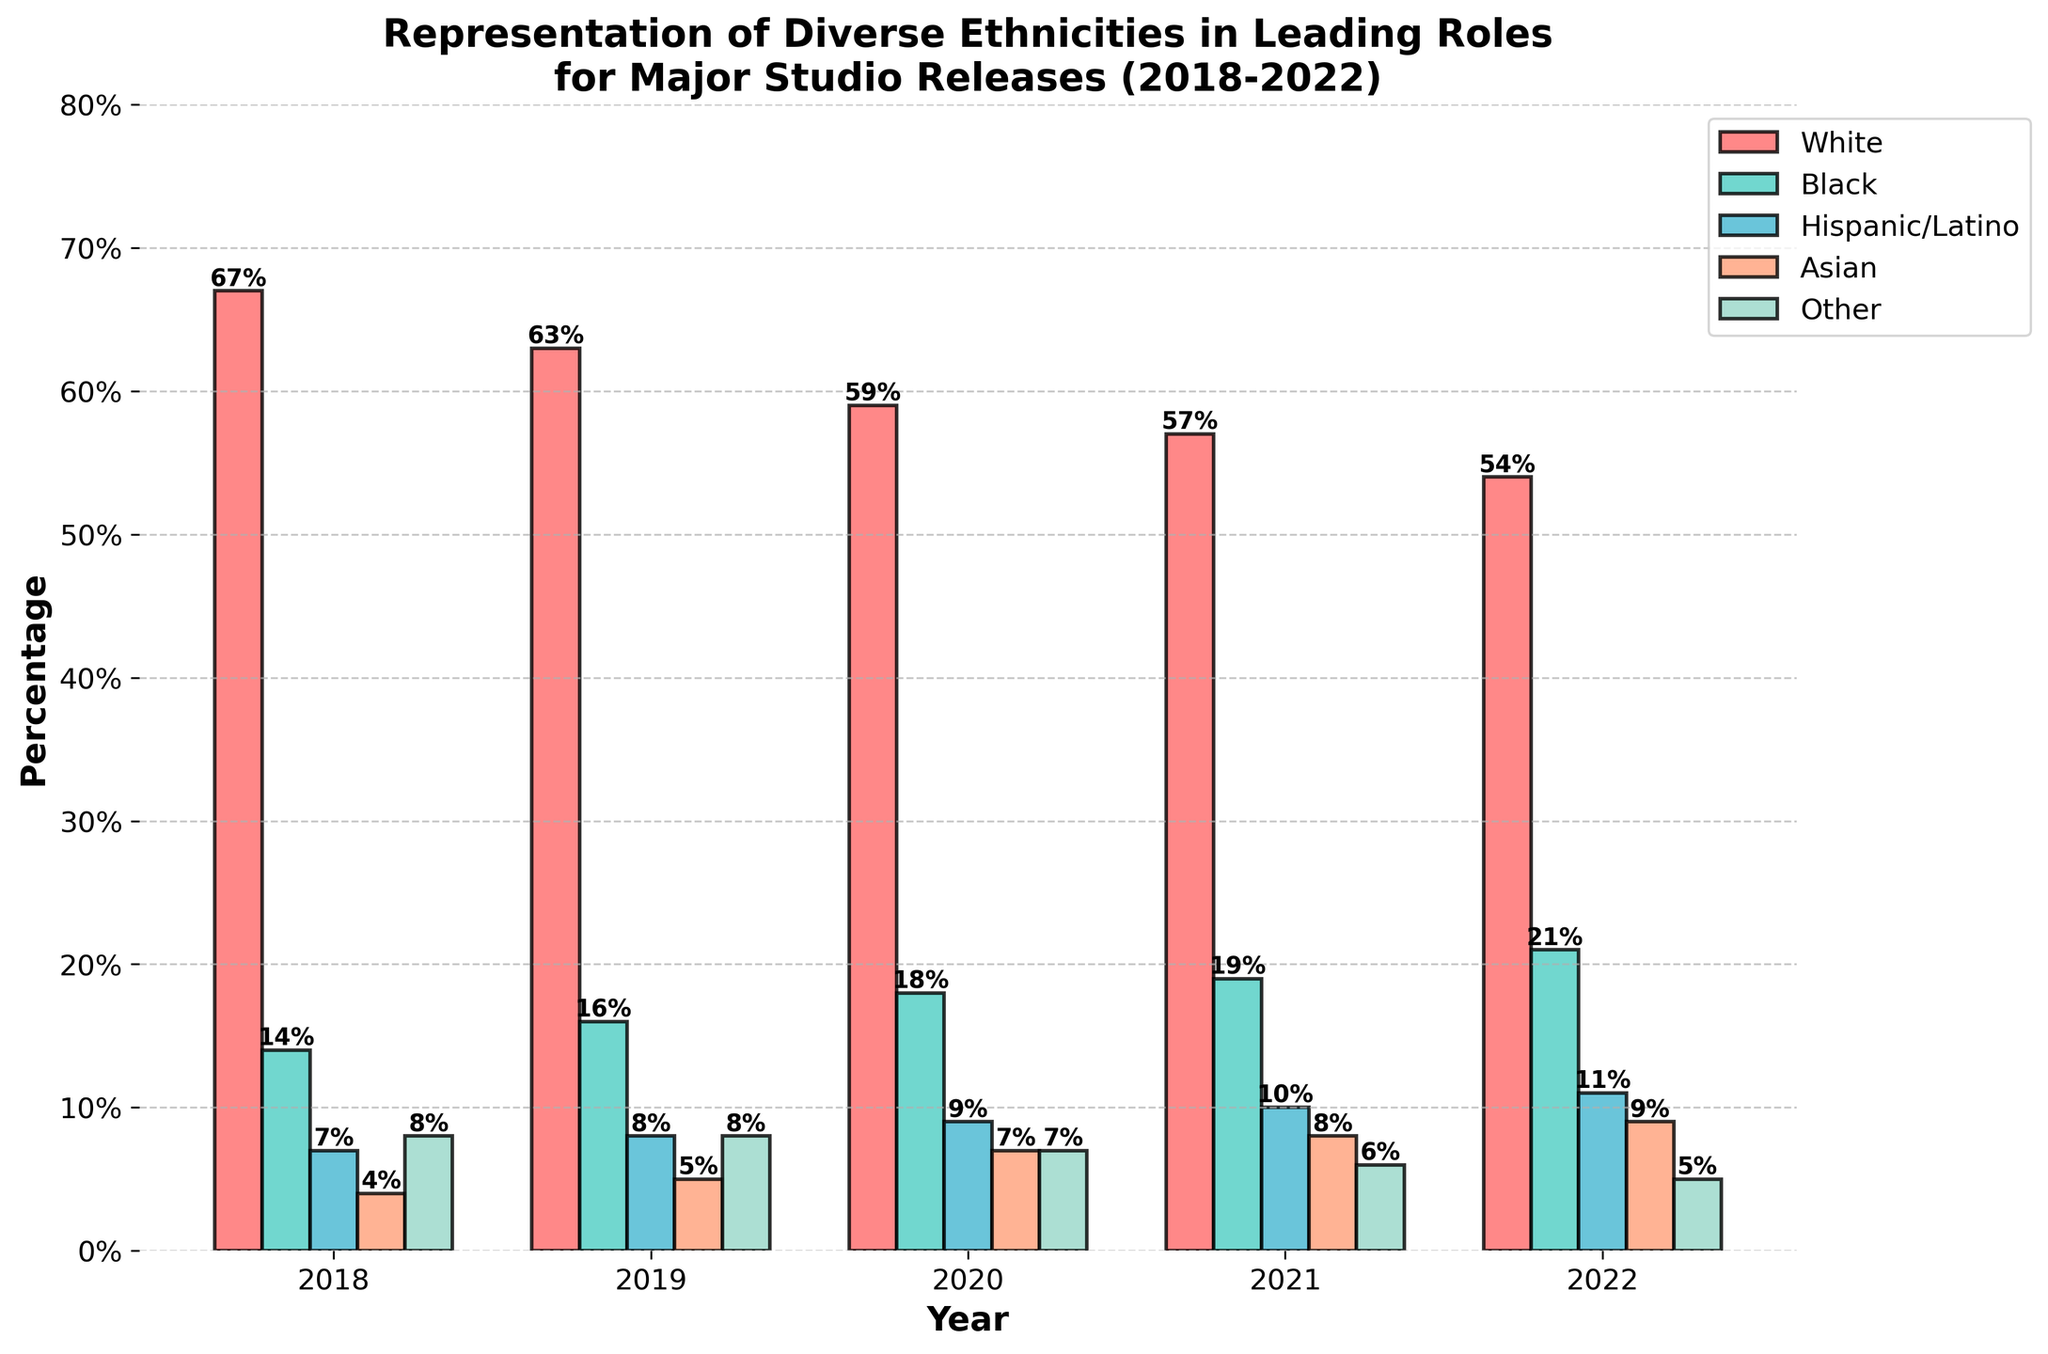What is the percentage increase in representation for Black leading roles from 2018 to 2022? In 2018, the percentage was 14%. By 2022, it increased to 21%. The difference is 21% - 14%, which equals 7%. To find the percentage increase, we calculate (7% / 14%) * 100% = 50%
Answer: 50% Which ethnicity had the highest representation in leading roles in 2022? By examining the 2022 bars, 'White' had the highest, with 54%.
Answer: White How did the percentage for Hispanic/Latino leading roles change between 2019 and 2021? In 2019, it was 8%. By 2021, it increased to 10%. The change is 10% - 8%, which is a 2% increase.
Answer: 2% Among the ethnicities, which one showed the most consistent increase in representation over the 5-year period? Looking at the trends of all ethnicities from 2018 to 2022, 'Black' consistently grew from 14% to 21%. This represents increases each year.
Answer: Black What is the sum of representations for Asian leading roles across all years? Add the percentages for 'Asian' for each year: 4% + 5% + 7% + 8% + 9% = 33%
Answer: 33% If you average the representation percentages for 'Other' roles from 2018 to 2022, what would it be? The values are 8%, 8%, 7%, 6%, and 5%. Sum these up: 8 + 8 + 7 + 6 + 5 = 34. The average is 34 / 5 = 6.8%
Answer: 6.8% Which two ethnicities had the closest representation percentages in 2020? In 2020, the representations were: White 59%, Black 18%, Hispanic/Latino 9%, Asian 7%, and Other 7%. 'Asian' and 'Other' both had 7%, so these are the closest.
Answer: Asian and Other Between 2018 and 2022, which ethnicity saw a decrease in its representation percentage? Look at each ethnicity's trend over the years. 'Other' started at 8% in 2018 and ended at 5% in 2022.
Answer: Other Comparatively, how much larger was the percentage of White leading roles in 2018 compared to the combined percentage of Asian and Hispanic/Latino leading roles that same year? In 2018, White had 67%. Combined Asian and Hispanic/Latino roles were 4% + 7% = 11%. The difference is 67% - 11% = 56%.
Answer: 56% What was the total representation percentage for all ethnicities in 2021? Add all percentages for 2021: 57% (White) + 19% (Black) + 10% (Hispanic/Latino) + 8% (Asian) + 6% (Other) = 100%
Answer: 100% 